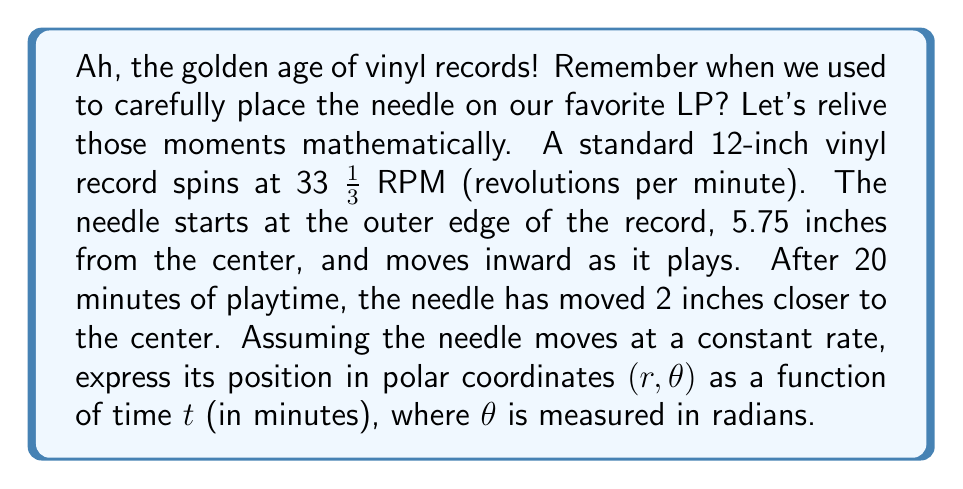Give your solution to this math problem. Let's approach this nostalgic problem step by step:

1) First, let's consider the radius $r$. We know:
   - Initial radius: $r_0 = 5.75$ inches
   - After 20 minutes, radius has decreased by 2 inches
   - Rate of change of radius: $\frac{2 \text{ inches}}{20 \text{ minutes}} = 0.1 \text{ inches/minute}$

   So, we can express $r$ as a function of time:
   $$r(t) = 5.75 - 0.1t$$

2) Now, let's consider the angle $\theta$. We know:
   - The record spins at 33 1/3 RPM = $\frac{100}{3}$ RPM
   - In one minute, the record completes $\frac{100}{3}$ revolutions
   - One revolution is $2\pi$ radians

   So, in one minute, the angle covered is:
   $$\frac{100}{3} \cdot 2\pi = \frac{200\pi}{3} \text{ radians/minute}$$

   Therefore, $\theta$ as a function of time is:
   $$\theta(t) = \frac{200\pi}{3}t$$

3) Combining these, we get the polar coordinate function:
   $$\left(r(t), \theta(t)\right) = \left(5.75 - 0.1t, \frac{200\pi}{3}t\right)$$
Answer: The position of the needle in polar coordinates as a function of time $t$ (in minutes) is:

$$(r,\theta) = \left(5.75 - 0.1t, \frac{200\pi}{3}t\right)$$

where $r$ is measured in inches and $\theta$ in radians. 